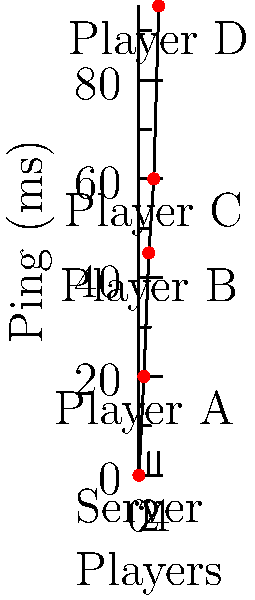As a Twitch streamer showcasing an AI-designed multiplayer game, you notice varying ping times among players. The graph shows ping times for four players connecting to the game server. Which player is most likely to experience noticeable lag or delay in their gameplay, and approximately how many milliseconds behind the server will their actions appear? To determine which player will experience the most noticeable lag and how far behind their actions will appear, we need to analyze the ping times shown in the graph:

1. Identify the ping times for each player:
   - Player A: ~20 ms
   - Player B: ~45 ms
   - Player C: ~60 ms
   - Player D: ~95 ms

2. The player with the highest ping time will experience the most noticeable lag. In this case, it's Player D with ~95 ms.

3. The delay in gameplay is approximately half the round-trip time (RTT). The RTT is represented by the ping time.

4. To calculate the delay:
   $\text{Delay} \approx \frac{\text{Ping time}}{2}$

5. For Player D:
   $\text{Delay} \approx \frac{95 \text{ ms}}{2} \approx 47.5 \text{ ms}$

Therefore, Player D is most likely to experience noticeable lag, and their actions will appear approximately 47.5 ms behind the server.
Answer: Player D, ~47.5 ms behind 